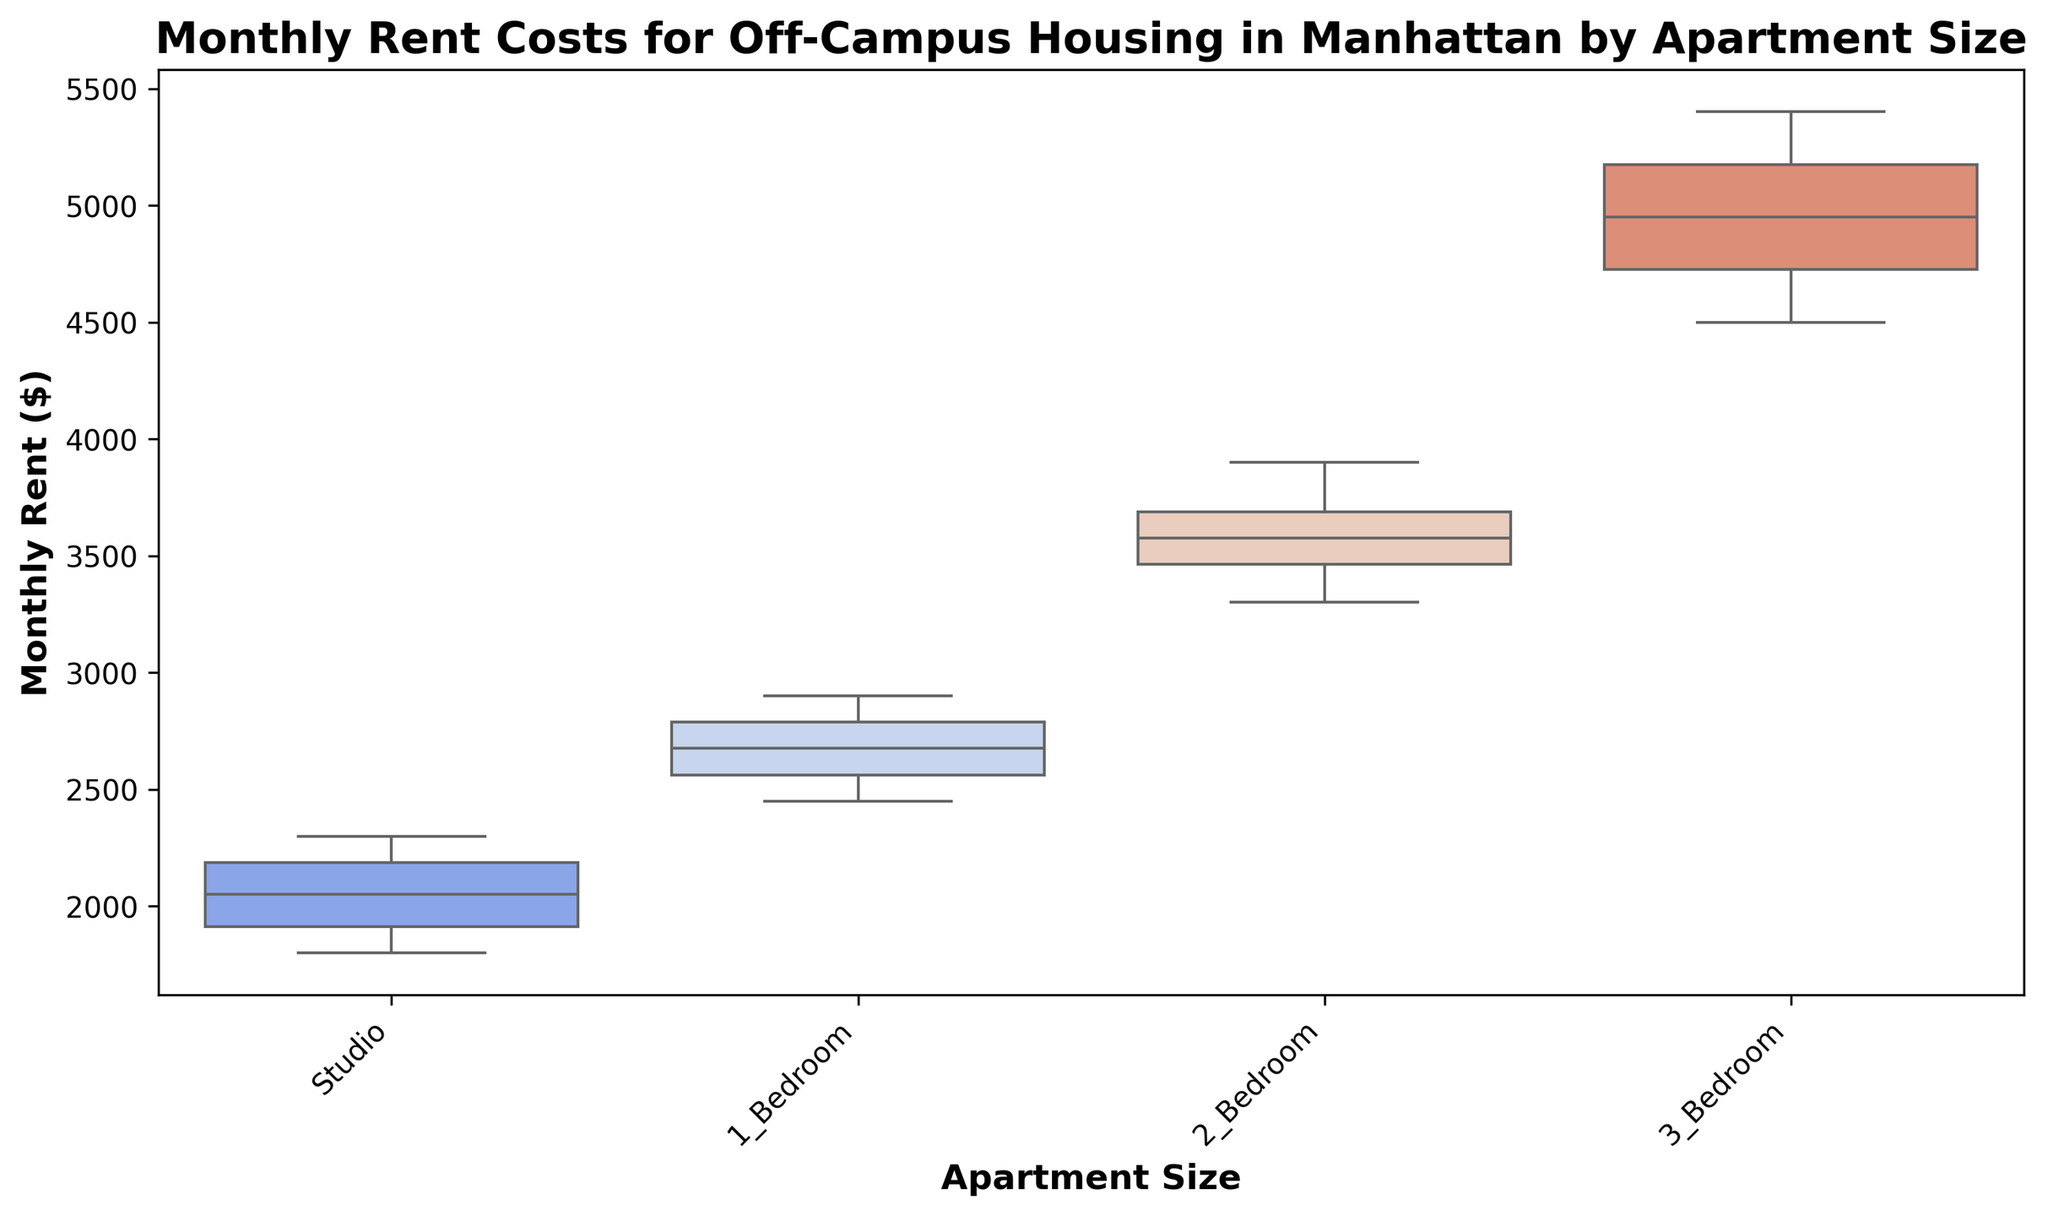What is the median monthly rent for a 1 Bedroom apartment? The median rent is the middle value in the sorted list of rents. For 1 Bedroom, the sorted rents are 2450, 2500, 2550, 2600, 2650, 2700, 2750, 2800, 2850, 2900. The median is (2650 + 2700) / 2 = 2675
Answer: 2675 Which apartment size has the highest median rent? Looking at the box plot, the highest median line corresponds to the 3 Bedroom apartments.
Answer: 3 Bedroom What is the interquartile range (IQR) for Studio apartments? The IQR is the difference between the third quartile (Q3) and the first quartile (Q1). For Studio apartments, Q3 is approximately 2200 and Q1 is approximately 1900, so IQR = 2200 - 1900 = 300
Answer: 300 Comparing 2 Bedroom and 1 Bedroom apartments, which has a wider range of monthly rents? The range is the difference between the maximum and minimum values. For 2 Bedroom apartments, the range is 3900 - 3300 = 600. For 1 Bedroom apartments, the range is 2900 - 2450 = 450. Therefore, 2 Bedroom apartments have a wider range.
Answer: 2 Bedroom Are there any outliers seen in the box plot for any apartment sizes? By examining the box plot, there are no points that fall outside the whiskers, indicating there are no outliers for any of the apartment sizes.
Answer: No What is the median rent difference between Studio and 2 Bedroom apartments? The median rent for Studio apartments is around 2050 and for 2 Bedroom apartments, it is around 3550. The difference is 3550 - 2050 = 1500
Answer: 1500 How does the variability of rent in 3 Bedroom apartments compare to Studio apartments? Variability can be assessed using the IQR. For 3 Bedroom apartments, Q3 ≈ 5200, Q1 ≈ 4600, so IQR = 600. For Studio apartments, as calculated earlier, IQR = 300. 3 Bedroom apartments have greater variability.
Answer: 3 Bedroom has greater variability Which apartment size has the smallest interquartile range? By visually comparing the box plots, the Studio apartments have the shortest box, indicating the smallest IQR.
Answer: Studio What is the range of rents for a 3 Bedroom apartment? The range is the difference between the maximum and minimum values. For 3 Bedroom apartments, the max is 5400 and the min is 4500, so the range = 5400 - 4500 = 900
Answer: 900 What is the approximate median rent for the Studio apartments? The median rent for Studio apartments, indicated by the central line of the box, is approximately 2050.
Answer: 2050 